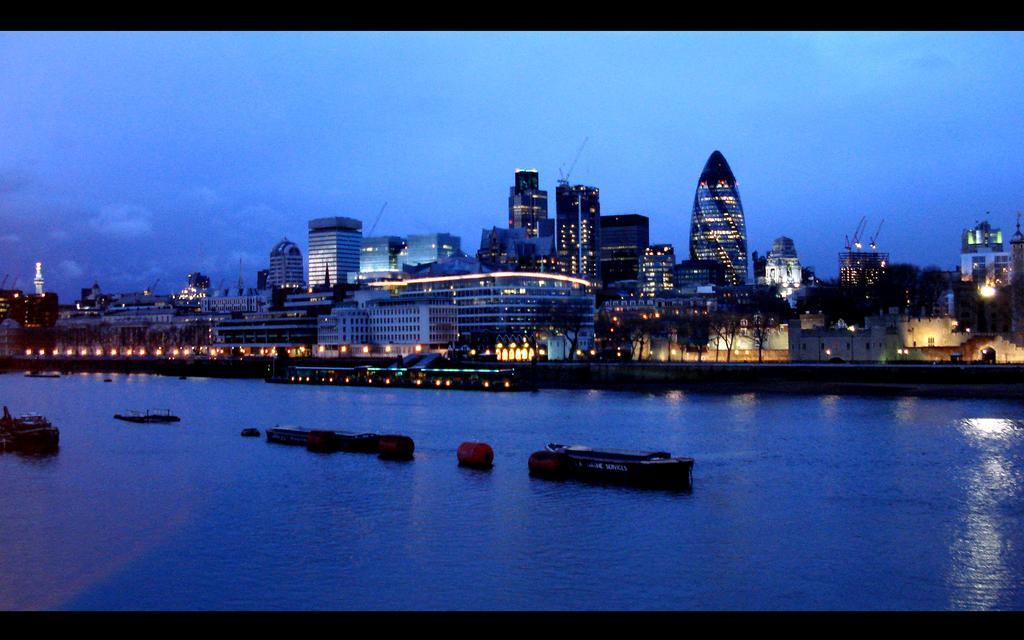Please provide a concise description of this image. In this image I can see few boats and few other objects on the surface of the water and in the background I can see few lights, few trees, few buildings and the sky. 